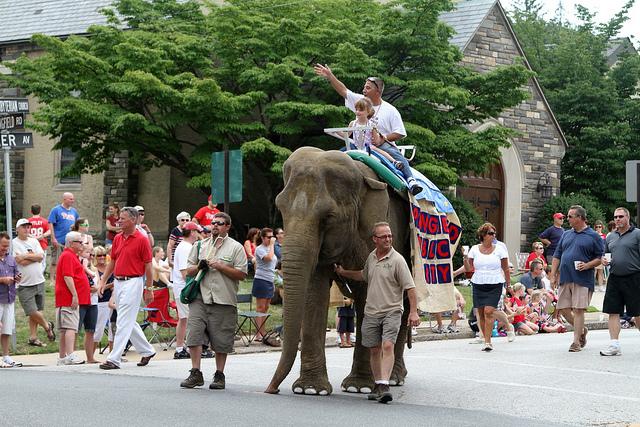What color is the elephant?
Give a very brief answer. Gray. How many streets are at this intersection?
Be succinct. 3. Is this a parade?
Answer briefly. Yes. 